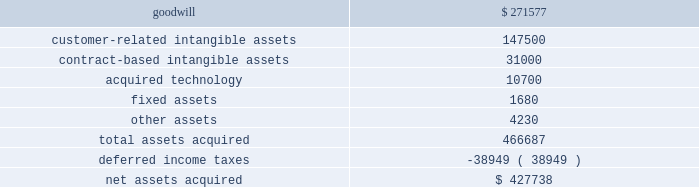Cash and a commitment to fund the capital needs of the business until such time as its cumulative funding is equal to funding that we have provided from inception through the effective date of the transaction .
The transaction created a new joint venture which does business as comercia global payments brazil .
As a result of the transaction , we deconsolidated global payments brazil , and we apply the equity method of accounting to our retained interest in comercia global payments brazil .
We recorded a gain on the transaction of $ 2.1 million which is included in interest and other income in the consolidated statement of income for the fiscal year ended may 31 , 2014 .
The results of the brazil operation from inception until the restructuring into a joint venture on september 30 , 2013 were not material to our consolidated results of operations , and the assets and liabilities that we derecognized were not material to our consolidated balance sheet .
American express portfolio on october 24 , 2013 , we acquired a merchant portfolio in the czech republic from american express limited for $ 1.9 million .
The acquired assets have been classified as customer-related intangible assets and contract-based intangible assets with estimated amortization periods of 10 years .
Paypros on march 4 , 2014 , we completed the acquisition of 100% ( 100 % ) of the outstanding stock of payment processing , inc .
( 201cpaypros 201d ) for $ 420.0 million in cash plus $ 7.7 million in cash for working capital , subject to adjustment based on a final determination of working capital .
We funded the acquisition with a combination of cash on hand and proceeds from our new term loan .
Paypros , based in california , is a provider of fully-integrated payment solutions for small-to-medium sized merchants in the united states .
Paypros delivers its products and services through a network of technology-based enterprise software partners to vertical markets that are complementary to the markets served by accelerated payment technologies ( 201capt 201d ) , which we acquired in october 2012 .
We acquired paypros to expand our direct distribution capabilities in the united states and to further enhance our existing integrated solutions offerings .
This acquisition was recorded as a business combination , and the purchase price was allocated to the assets acquired and liabilities assumed based on their estimated fair values .
Due to the timing of this transaction , the allocation of the purchase price is preliminary pending final valuation of intangible assets and deferred income taxes as well as resolution of the working capital settlement discussed above .
The purchase price of paypros was determined by analyzing the historical and prospective financial statements .
Acquisition costs associated with this purchase were not material .
The table summarizes the preliminary purchase price allocation ( in thousands ) : .
The preliminary purchase price allocation resulted in goodwill , included in the north america merchant services segment , of $ 271.6 million .
Such goodwill is attributable primarily to synergies with the services offered and markets served by paypros .
The goodwill associated with the acquisition is not deductible for tax purposes .
The customer-related intangible assets and the contract-based intangible assets have an estimated amortization period of 13 years .
The acquired technology has an estimated amortization period of 7 years. .
What will be the yearly amortization expense related to acquired technology , ( in thousands ) ? 
Computations: (10700 / 7)
Answer: 1528.57143. 